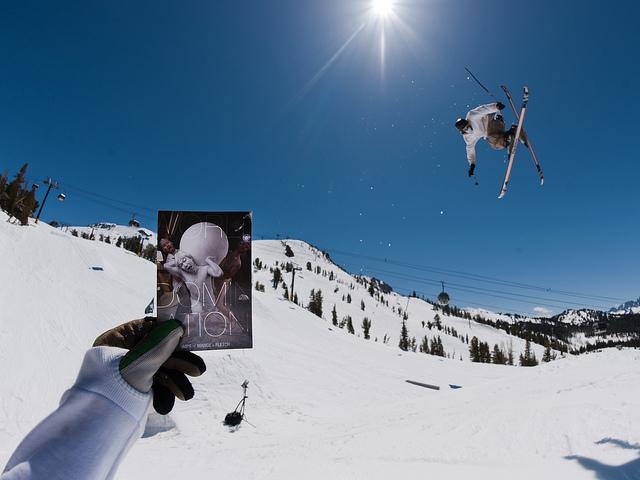Are the people flying?
Keep it brief. No. Is the sun on the left or right side of this picture?
Concise answer only. Right. Does the chair lift have covered chairs?
Answer briefly. Yes. Is the sun high in the sky?
Short answer required. Yes. What sport is being shown?
Keep it brief. Skiing. How many people are wearing green?
Give a very brief answer. 0. What is the hand holding?
Be succinct. Picture. What is the bright object above the skier?
Quick response, please. Sun. 